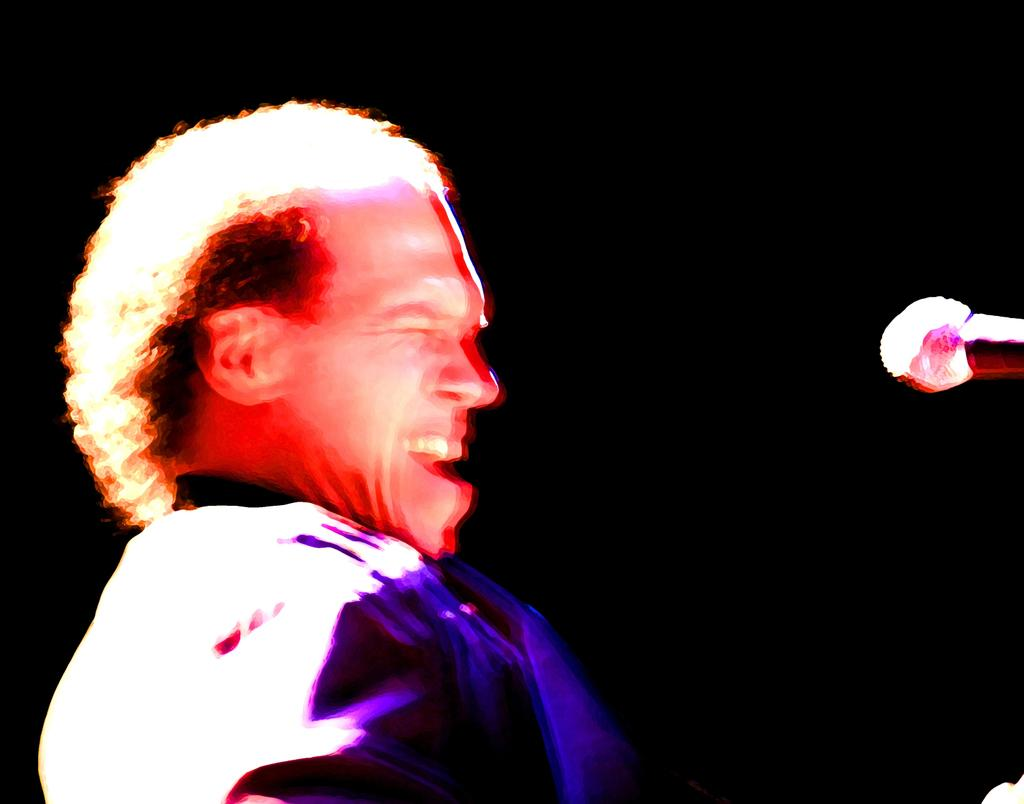What is the general color scheme of the background in the image? The background of the image is dark. Where is the man located in the image? The man is on the left side of the image. How clear is the man's facial detail in the image? The man's face is a little blurred in the image. What can be seen on the right side of the image? There is a mic on the right side of the image. Can you see any actors performing in space in the image? There are no actors or space depicted in the image; it features a man and a mic in a dark background. Is there a match being lit in the image? There is no match or any indication of fire in the image. 